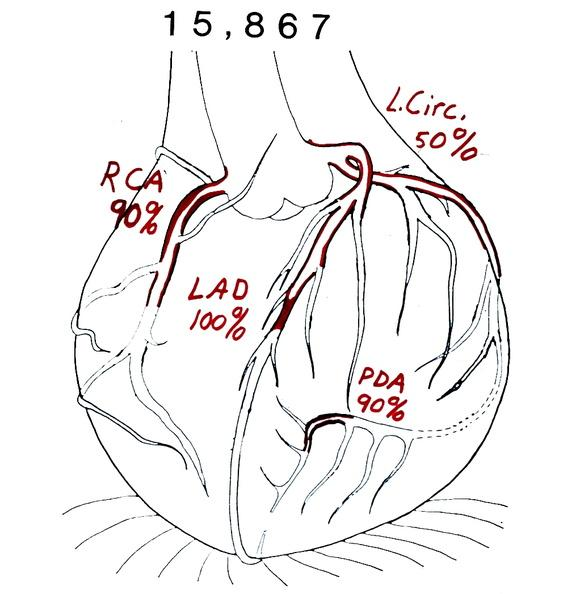where is this area in the body?
Answer the question using a single word or phrase. Heart 